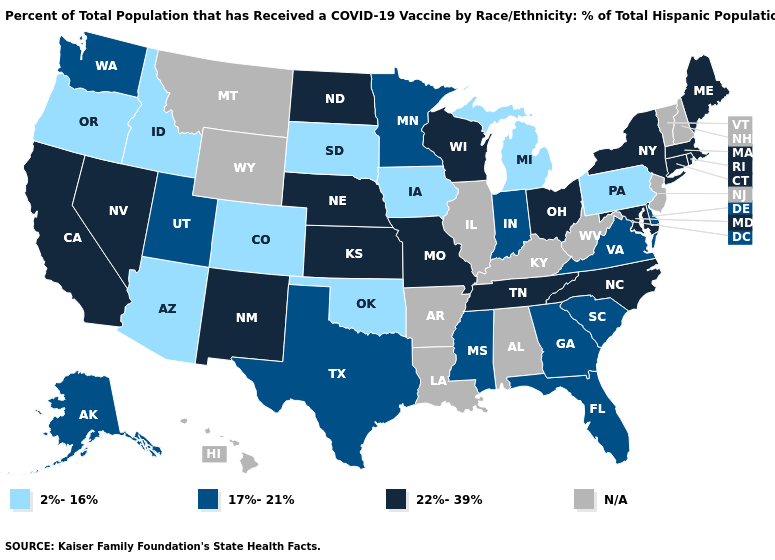What is the highest value in states that border Oregon?
Keep it brief. 22%-39%. How many symbols are there in the legend?
Keep it brief. 4. Name the states that have a value in the range 22%-39%?
Be succinct. California, Connecticut, Kansas, Maine, Maryland, Massachusetts, Missouri, Nebraska, Nevada, New Mexico, New York, North Carolina, North Dakota, Ohio, Rhode Island, Tennessee, Wisconsin. What is the value of Oregon?
Short answer required. 2%-16%. Which states have the highest value in the USA?
Short answer required. California, Connecticut, Kansas, Maine, Maryland, Massachusetts, Missouri, Nebraska, Nevada, New Mexico, New York, North Carolina, North Dakota, Ohio, Rhode Island, Tennessee, Wisconsin. Does North Dakota have the highest value in the MidWest?
Write a very short answer. Yes. Name the states that have a value in the range 2%-16%?
Write a very short answer. Arizona, Colorado, Idaho, Iowa, Michigan, Oklahoma, Oregon, Pennsylvania, South Dakota. What is the highest value in states that border Minnesota?
Give a very brief answer. 22%-39%. What is the value of New Mexico?
Quick response, please. 22%-39%. Name the states that have a value in the range 17%-21%?
Quick response, please. Alaska, Delaware, Florida, Georgia, Indiana, Minnesota, Mississippi, South Carolina, Texas, Utah, Virginia, Washington. What is the highest value in the USA?
Keep it brief. 22%-39%. Among the states that border Texas , does Oklahoma have the lowest value?
Answer briefly. Yes. Does Texas have the highest value in the USA?
Quick response, please. No. 